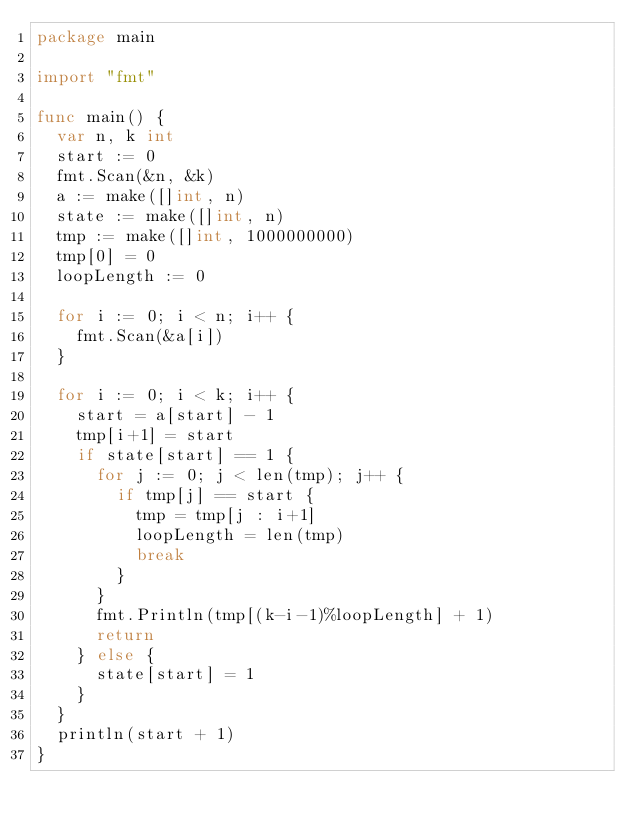<code> <loc_0><loc_0><loc_500><loc_500><_Go_>package main

import "fmt"

func main() {
	var n, k int
	start := 0
	fmt.Scan(&n, &k)
	a := make([]int, n)
	state := make([]int, n)
	tmp := make([]int, 1000000000)
	tmp[0] = 0
	loopLength := 0

	for i := 0; i < n; i++ {
		fmt.Scan(&a[i])
	}

	for i := 0; i < k; i++ {
		start = a[start] - 1
		tmp[i+1] = start
		if state[start] == 1 {
			for j := 0; j < len(tmp); j++ {
				if tmp[j] == start {
					tmp = tmp[j : i+1]
					loopLength = len(tmp)
					break
				}
			}
			fmt.Println(tmp[(k-i-1)%loopLength] + 1)
			return
		} else {
			state[start] = 1
		}
	}
	println(start + 1)
}
</code> 